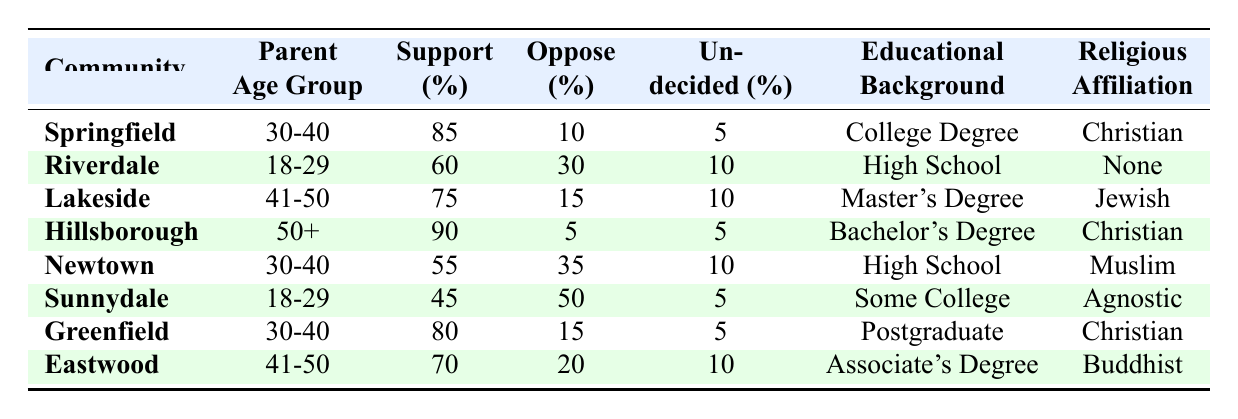What percentage of parents in Springfield support abstinence-only education? From the table, we can see that the percentage of parents who support abstinence-only education in Springfield is listed as 85%.
Answer: 85% Which community has the lowest support for abstinence-only education among those surveyed? By looking at the support percentages, we can see that Sunnydale has the lowest support at 45%.
Answer: Sunnydale How many communities have a support percentage of 70% or higher for abstinence-only education? Checking the support percentages, Springfield (85%), Hillsborough (90%), Lakeside (75%), Greenfield (80%), and Eastwood (70%) meet this criterion: that's 5 communities.
Answer: 5 What is the average support for abstinence-only education among communities with a religious affiliation of "Christian"? The communities with a "Christian" affiliation are Springfield (85%), Hillsborough (90%), and Greenfield (80%). The total support is 255% (85 + 90 + 80), so the average is 255/3 = 85%.
Answer: 85% What percentage of parents in Newtown oppose abstinence-only education? The table shows that in Newtown, 35% of parents oppose abstinence-only education.
Answer: 35% Is there a community where more parents oppose abstinence-only education than support it? In Sunnydale, 50% of parents oppose abstinence-only education while only 45% support it. Thus, this statement is true.
Answer: Yes Which parent age group in Hillsborough shows the highest support for abstinence-only education? From the table, we see that the percentage of support in Hillsborough, which corresponds to the 50+ age group, is 90%, the highest among all listed age groups.
Answer: 90% How many percentage points higher is the support for abstinence-only education in Springfield compared to Newtown? Springfield has 85% support and Newtown has 55% support. The difference is 85 - 55 = 30 percentage points.
Answer: 30 Which community has a higher percentage of undecided parents, Lakeside or Eastwood? Lakeside has 10% undecided parents, and Eastwood has 10% as well. They are equal, so neither has a higher percentage.
Answer: Neither What is the total percentage of parents who are undecided across all communities? The total percent of undecided parents is calculated as follows: 5 (Springfield) + 10 (Riverdale) + 10 (Lakeside) + 5 (Hillsborough) + 10 (Newtown) + 5 (Sunnydale) + 5 (Greenfield) + 10 (Eastwood) = 60%.
Answer: 60% 